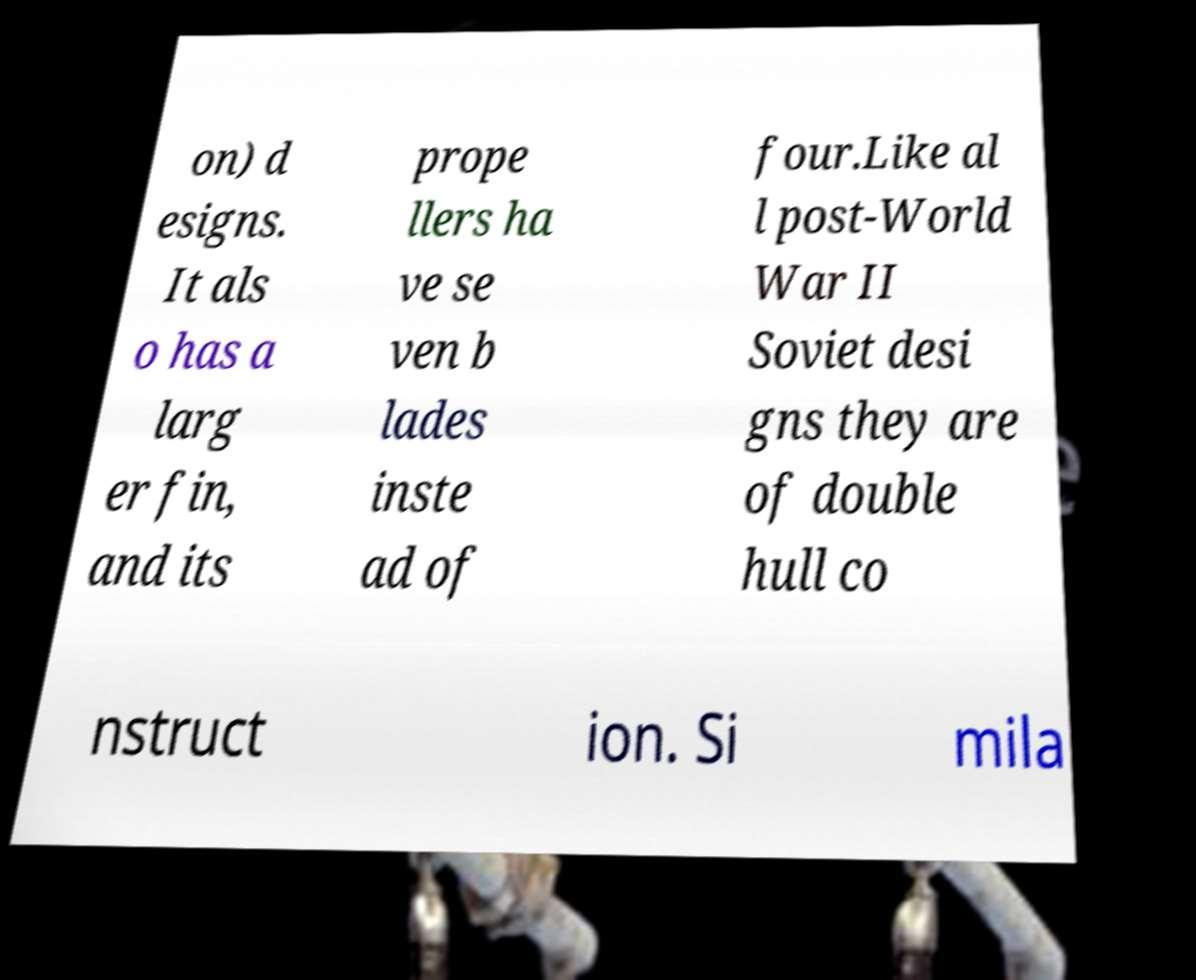There's text embedded in this image that I need extracted. Can you transcribe it verbatim? on) d esigns. It als o has a larg er fin, and its prope llers ha ve se ven b lades inste ad of four.Like al l post-World War II Soviet desi gns they are of double hull co nstruct ion. Si mila 